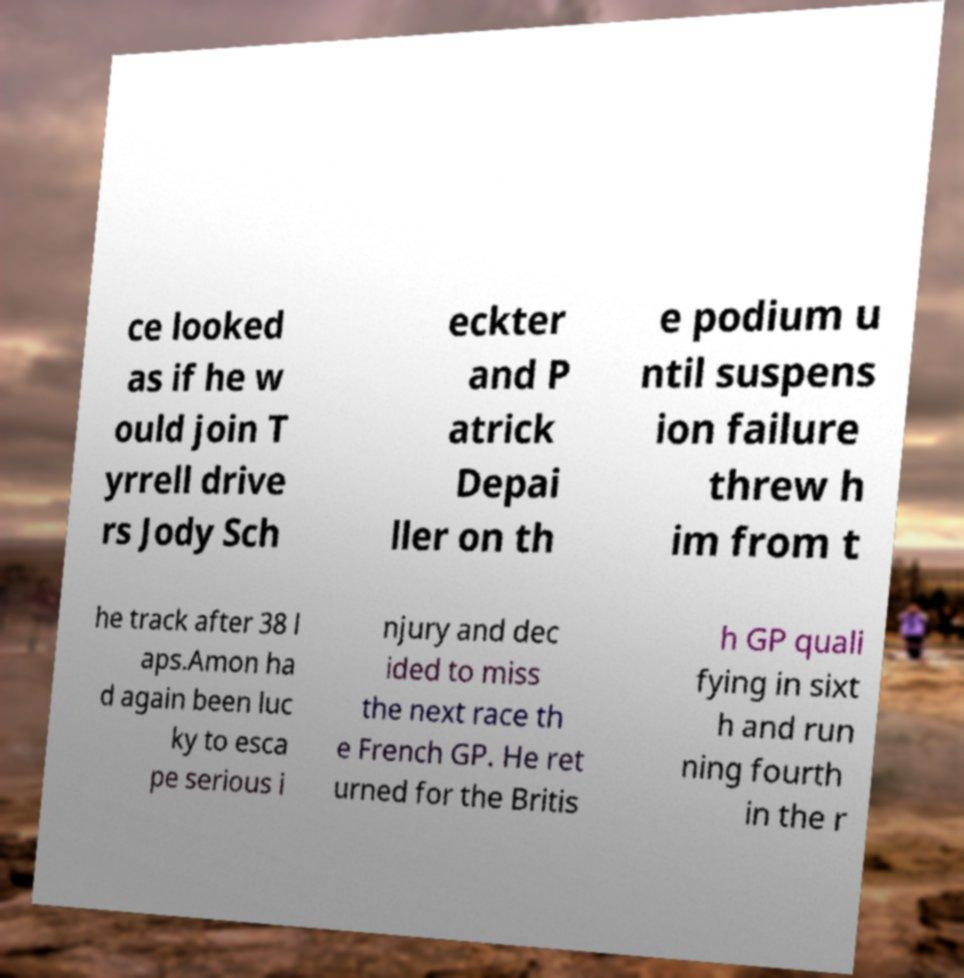Please identify and transcribe the text found in this image. ce looked as if he w ould join T yrrell drive rs Jody Sch eckter and P atrick Depai ller on th e podium u ntil suspens ion failure threw h im from t he track after 38 l aps.Amon ha d again been luc ky to esca pe serious i njury and dec ided to miss the next race th e French GP. He ret urned for the Britis h GP quali fying in sixt h and run ning fourth in the r 